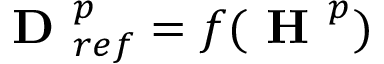Convert formula to latex. <formula><loc_0><loc_0><loc_500><loc_500>D _ { r e f } ^ { p } = f ( H ^ { p } )</formula> 